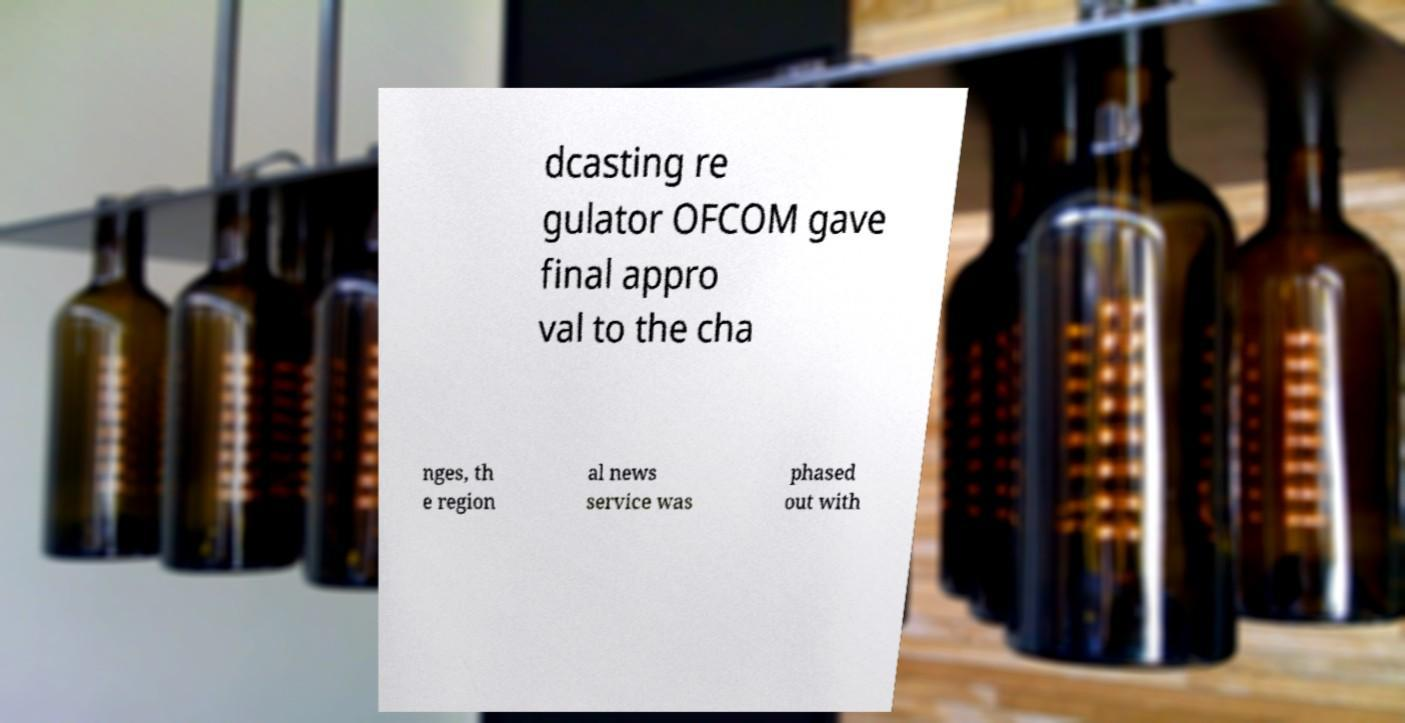Please read and relay the text visible in this image. What does it say? dcasting re gulator OFCOM gave final appro val to the cha nges, th e region al news service was phased out with 